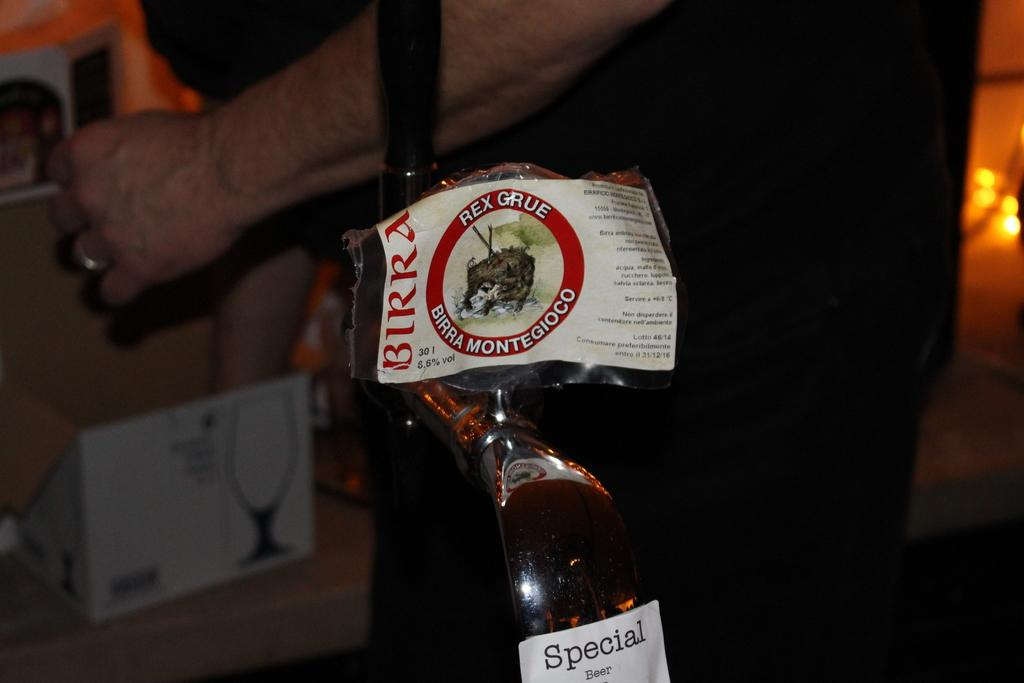<image>
Render a clear and concise summary of the photo. A bottle of BIRRA alcohol has 5.6% alcohol. 